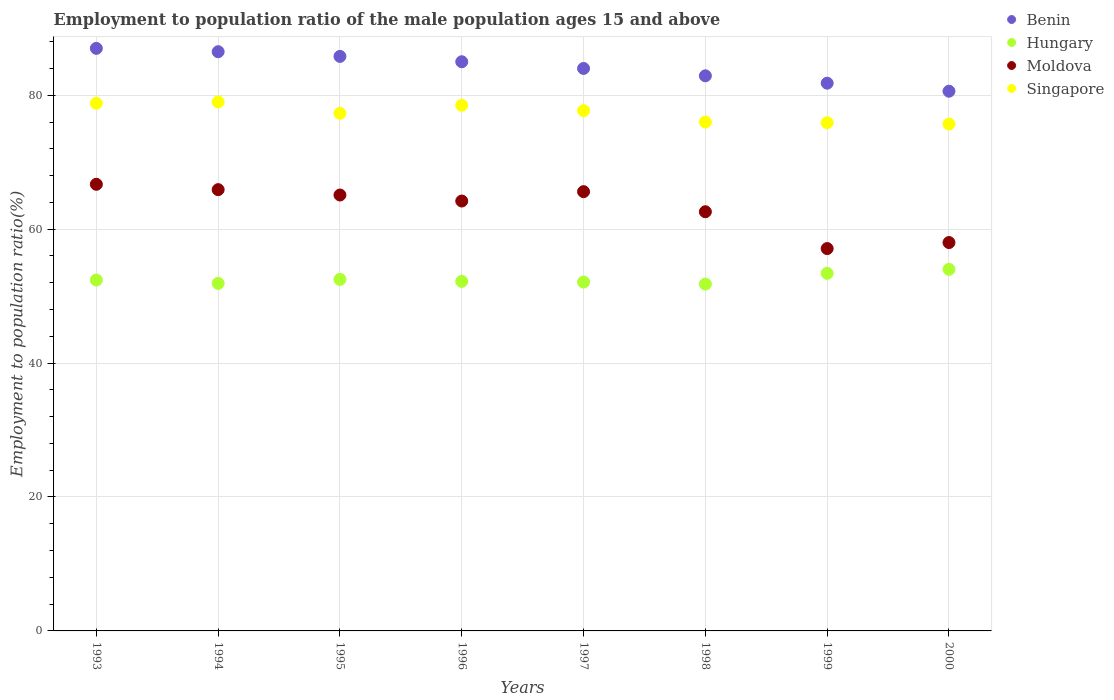How many different coloured dotlines are there?
Give a very brief answer. 4. What is the employment to population ratio in Hungary in 1998?
Your answer should be compact. 51.8. Across all years, what is the maximum employment to population ratio in Singapore?
Ensure brevity in your answer.  79. Across all years, what is the minimum employment to population ratio in Hungary?
Your answer should be compact. 51.8. What is the total employment to population ratio in Hungary in the graph?
Give a very brief answer. 420.3. What is the difference between the employment to population ratio in Moldova in 1997 and that in 1998?
Provide a short and direct response. 3. What is the difference between the employment to population ratio in Singapore in 1994 and the employment to population ratio in Benin in 1995?
Your response must be concise. -6.8. What is the average employment to population ratio in Singapore per year?
Your answer should be compact. 77.36. In the year 1997, what is the difference between the employment to population ratio in Moldova and employment to population ratio in Benin?
Your answer should be compact. -18.4. In how many years, is the employment to population ratio in Singapore greater than 84 %?
Keep it short and to the point. 0. What is the ratio of the employment to population ratio in Hungary in 1997 to that in 1998?
Your answer should be compact. 1.01. What is the difference between the highest and the second highest employment to population ratio in Singapore?
Keep it short and to the point. 0.2. What is the difference between the highest and the lowest employment to population ratio in Singapore?
Offer a very short reply. 3.3. In how many years, is the employment to population ratio in Benin greater than the average employment to population ratio in Benin taken over all years?
Offer a terse response. 4. Is it the case that in every year, the sum of the employment to population ratio in Hungary and employment to population ratio in Benin  is greater than the sum of employment to population ratio in Singapore and employment to population ratio in Moldova?
Provide a short and direct response. No. Is the employment to population ratio in Hungary strictly less than the employment to population ratio in Benin over the years?
Give a very brief answer. Yes. Are the values on the major ticks of Y-axis written in scientific E-notation?
Your answer should be very brief. No. Where does the legend appear in the graph?
Your answer should be very brief. Top right. How many legend labels are there?
Keep it short and to the point. 4. How are the legend labels stacked?
Give a very brief answer. Vertical. What is the title of the graph?
Offer a terse response. Employment to population ratio of the male population ages 15 and above. What is the label or title of the X-axis?
Keep it short and to the point. Years. What is the label or title of the Y-axis?
Offer a terse response. Employment to population ratio(%). What is the Employment to population ratio(%) of Hungary in 1993?
Your answer should be compact. 52.4. What is the Employment to population ratio(%) of Moldova in 1993?
Your answer should be very brief. 66.7. What is the Employment to population ratio(%) of Singapore in 1993?
Offer a terse response. 78.8. What is the Employment to population ratio(%) in Benin in 1994?
Your answer should be very brief. 86.5. What is the Employment to population ratio(%) of Hungary in 1994?
Your answer should be compact. 51.9. What is the Employment to population ratio(%) in Moldova in 1994?
Your answer should be compact. 65.9. What is the Employment to population ratio(%) of Singapore in 1994?
Keep it short and to the point. 79. What is the Employment to population ratio(%) in Benin in 1995?
Your answer should be very brief. 85.8. What is the Employment to population ratio(%) of Hungary in 1995?
Your response must be concise. 52.5. What is the Employment to population ratio(%) in Moldova in 1995?
Make the answer very short. 65.1. What is the Employment to population ratio(%) in Singapore in 1995?
Your answer should be very brief. 77.3. What is the Employment to population ratio(%) in Hungary in 1996?
Give a very brief answer. 52.2. What is the Employment to population ratio(%) in Moldova in 1996?
Offer a terse response. 64.2. What is the Employment to population ratio(%) in Singapore in 1996?
Offer a very short reply. 78.5. What is the Employment to population ratio(%) of Hungary in 1997?
Give a very brief answer. 52.1. What is the Employment to population ratio(%) of Moldova in 1997?
Your answer should be very brief. 65.6. What is the Employment to population ratio(%) in Singapore in 1997?
Your answer should be very brief. 77.7. What is the Employment to population ratio(%) in Benin in 1998?
Provide a succinct answer. 82.9. What is the Employment to population ratio(%) of Hungary in 1998?
Keep it short and to the point. 51.8. What is the Employment to population ratio(%) in Moldova in 1998?
Offer a very short reply. 62.6. What is the Employment to population ratio(%) in Singapore in 1998?
Keep it short and to the point. 76. What is the Employment to population ratio(%) of Benin in 1999?
Provide a succinct answer. 81.8. What is the Employment to population ratio(%) in Hungary in 1999?
Give a very brief answer. 53.4. What is the Employment to population ratio(%) of Moldova in 1999?
Your answer should be compact. 57.1. What is the Employment to population ratio(%) in Singapore in 1999?
Make the answer very short. 75.9. What is the Employment to population ratio(%) in Benin in 2000?
Provide a succinct answer. 80.6. What is the Employment to population ratio(%) of Moldova in 2000?
Keep it short and to the point. 58. What is the Employment to population ratio(%) in Singapore in 2000?
Offer a terse response. 75.7. Across all years, what is the maximum Employment to population ratio(%) in Hungary?
Offer a very short reply. 54. Across all years, what is the maximum Employment to population ratio(%) of Moldova?
Ensure brevity in your answer.  66.7. Across all years, what is the maximum Employment to population ratio(%) of Singapore?
Provide a succinct answer. 79. Across all years, what is the minimum Employment to population ratio(%) in Benin?
Give a very brief answer. 80.6. Across all years, what is the minimum Employment to population ratio(%) of Hungary?
Provide a succinct answer. 51.8. Across all years, what is the minimum Employment to population ratio(%) of Moldova?
Offer a very short reply. 57.1. Across all years, what is the minimum Employment to population ratio(%) of Singapore?
Keep it short and to the point. 75.7. What is the total Employment to population ratio(%) of Benin in the graph?
Your response must be concise. 673.6. What is the total Employment to population ratio(%) of Hungary in the graph?
Your answer should be compact. 420.3. What is the total Employment to population ratio(%) of Moldova in the graph?
Keep it short and to the point. 505.2. What is the total Employment to population ratio(%) of Singapore in the graph?
Your answer should be very brief. 618.9. What is the difference between the Employment to population ratio(%) of Benin in 1993 and that in 1994?
Ensure brevity in your answer.  0.5. What is the difference between the Employment to population ratio(%) of Hungary in 1993 and that in 1994?
Offer a very short reply. 0.5. What is the difference between the Employment to population ratio(%) of Benin in 1993 and that in 1995?
Your answer should be very brief. 1.2. What is the difference between the Employment to population ratio(%) of Benin in 1993 and that in 1996?
Provide a succinct answer. 2. What is the difference between the Employment to population ratio(%) in Hungary in 1993 and that in 1996?
Your response must be concise. 0.2. What is the difference between the Employment to population ratio(%) of Moldova in 1993 and that in 1996?
Make the answer very short. 2.5. What is the difference between the Employment to population ratio(%) of Hungary in 1993 and that in 1997?
Your answer should be compact. 0.3. What is the difference between the Employment to population ratio(%) in Moldova in 1993 and that in 1997?
Your response must be concise. 1.1. What is the difference between the Employment to population ratio(%) in Singapore in 1993 and that in 1997?
Make the answer very short. 1.1. What is the difference between the Employment to population ratio(%) of Benin in 1993 and that in 1999?
Provide a succinct answer. 5.2. What is the difference between the Employment to population ratio(%) in Hungary in 1993 and that in 1999?
Your answer should be compact. -1. What is the difference between the Employment to population ratio(%) of Benin in 1993 and that in 2000?
Offer a very short reply. 6.4. What is the difference between the Employment to population ratio(%) in Hungary in 1993 and that in 2000?
Offer a terse response. -1.6. What is the difference between the Employment to population ratio(%) of Singapore in 1993 and that in 2000?
Provide a short and direct response. 3.1. What is the difference between the Employment to population ratio(%) of Benin in 1994 and that in 1995?
Give a very brief answer. 0.7. What is the difference between the Employment to population ratio(%) in Moldova in 1994 and that in 1995?
Your response must be concise. 0.8. What is the difference between the Employment to population ratio(%) of Benin in 1994 and that in 1996?
Keep it short and to the point. 1.5. What is the difference between the Employment to population ratio(%) in Hungary in 1994 and that in 1996?
Keep it short and to the point. -0.3. What is the difference between the Employment to population ratio(%) in Moldova in 1994 and that in 1996?
Offer a very short reply. 1.7. What is the difference between the Employment to population ratio(%) in Benin in 1994 and that in 1997?
Give a very brief answer. 2.5. What is the difference between the Employment to population ratio(%) in Moldova in 1994 and that in 1997?
Provide a short and direct response. 0.3. What is the difference between the Employment to population ratio(%) of Singapore in 1994 and that in 1997?
Offer a terse response. 1.3. What is the difference between the Employment to population ratio(%) in Hungary in 1994 and that in 1998?
Provide a succinct answer. 0.1. What is the difference between the Employment to population ratio(%) of Moldova in 1994 and that in 1998?
Your answer should be very brief. 3.3. What is the difference between the Employment to population ratio(%) of Singapore in 1994 and that in 1998?
Make the answer very short. 3. What is the difference between the Employment to population ratio(%) in Benin in 1994 and that in 1999?
Your answer should be compact. 4.7. What is the difference between the Employment to population ratio(%) of Singapore in 1994 and that in 1999?
Your answer should be very brief. 3.1. What is the difference between the Employment to population ratio(%) in Hungary in 1994 and that in 2000?
Your answer should be very brief. -2.1. What is the difference between the Employment to population ratio(%) in Benin in 1995 and that in 1996?
Ensure brevity in your answer.  0.8. What is the difference between the Employment to population ratio(%) in Benin in 1995 and that in 1997?
Provide a succinct answer. 1.8. What is the difference between the Employment to population ratio(%) in Singapore in 1995 and that in 1997?
Give a very brief answer. -0.4. What is the difference between the Employment to population ratio(%) in Benin in 1995 and that in 1998?
Offer a terse response. 2.9. What is the difference between the Employment to population ratio(%) of Moldova in 1995 and that in 1998?
Offer a very short reply. 2.5. What is the difference between the Employment to population ratio(%) of Hungary in 1995 and that in 1999?
Ensure brevity in your answer.  -0.9. What is the difference between the Employment to population ratio(%) of Singapore in 1995 and that in 1999?
Your answer should be very brief. 1.4. What is the difference between the Employment to population ratio(%) in Hungary in 1995 and that in 2000?
Provide a succinct answer. -1.5. What is the difference between the Employment to population ratio(%) of Moldova in 1995 and that in 2000?
Give a very brief answer. 7.1. What is the difference between the Employment to population ratio(%) in Benin in 1996 and that in 1997?
Your answer should be very brief. 1. What is the difference between the Employment to population ratio(%) in Hungary in 1996 and that in 1997?
Ensure brevity in your answer.  0.1. What is the difference between the Employment to population ratio(%) of Singapore in 1996 and that in 1998?
Provide a short and direct response. 2.5. What is the difference between the Employment to population ratio(%) of Hungary in 1996 and that in 1999?
Make the answer very short. -1.2. What is the difference between the Employment to population ratio(%) in Benin in 1996 and that in 2000?
Offer a terse response. 4.4. What is the difference between the Employment to population ratio(%) of Moldova in 1996 and that in 2000?
Your response must be concise. 6.2. What is the difference between the Employment to population ratio(%) of Singapore in 1996 and that in 2000?
Offer a terse response. 2.8. What is the difference between the Employment to population ratio(%) of Moldova in 1997 and that in 2000?
Ensure brevity in your answer.  7.6. What is the difference between the Employment to population ratio(%) in Singapore in 1997 and that in 2000?
Your answer should be very brief. 2. What is the difference between the Employment to population ratio(%) in Hungary in 1998 and that in 1999?
Your answer should be very brief. -1.6. What is the difference between the Employment to population ratio(%) of Moldova in 1998 and that in 1999?
Offer a terse response. 5.5. What is the difference between the Employment to population ratio(%) of Singapore in 1998 and that in 1999?
Your answer should be very brief. 0.1. What is the difference between the Employment to population ratio(%) of Hungary in 1998 and that in 2000?
Keep it short and to the point. -2.2. What is the difference between the Employment to population ratio(%) in Benin in 1999 and that in 2000?
Your response must be concise. 1.2. What is the difference between the Employment to population ratio(%) of Singapore in 1999 and that in 2000?
Your response must be concise. 0.2. What is the difference between the Employment to population ratio(%) of Benin in 1993 and the Employment to population ratio(%) of Hungary in 1994?
Provide a succinct answer. 35.1. What is the difference between the Employment to population ratio(%) of Benin in 1993 and the Employment to population ratio(%) of Moldova in 1994?
Offer a terse response. 21.1. What is the difference between the Employment to population ratio(%) of Benin in 1993 and the Employment to population ratio(%) of Singapore in 1994?
Offer a very short reply. 8. What is the difference between the Employment to population ratio(%) of Hungary in 1993 and the Employment to population ratio(%) of Singapore in 1994?
Your answer should be compact. -26.6. What is the difference between the Employment to population ratio(%) in Moldova in 1993 and the Employment to population ratio(%) in Singapore in 1994?
Keep it short and to the point. -12.3. What is the difference between the Employment to population ratio(%) in Benin in 1993 and the Employment to population ratio(%) in Hungary in 1995?
Provide a short and direct response. 34.5. What is the difference between the Employment to population ratio(%) of Benin in 1993 and the Employment to population ratio(%) of Moldova in 1995?
Ensure brevity in your answer.  21.9. What is the difference between the Employment to population ratio(%) of Hungary in 1993 and the Employment to population ratio(%) of Singapore in 1995?
Your answer should be compact. -24.9. What is the difference between the Employment to population ratio(%) of Benin in 1993 and the Employment to population ratio(%) of Hungary in 1996?
Your answer should be compact. 34.8. What is the difference between the Employment to population ratio(%) of Benin in 1993 and the Employment to population ratio(%) of Moldova in 1996?
Give a very brief answer. 22.8. What is the difference between the Employment to population ratio(%) in Benin in 1993 and the Employment to population ratio(%) in Singapore in 1996?
Keep it short and to the point. 8.5. What is the difference between the Employment to population ratio(%) of Hungary in 1993 and the Employment to population ratio(%) of Moldova in 1996?
Offer a very short reply. -11.8. What is the difference between the Employment to population ratio(%) of Hungary in 1993 and the Employment to population ratio(%) of Singapore in 1996?
Your answer should be very brief. -26.1. What is the difference between the Employment to population ratio(%) in Moldova in 1993 and the Employment to population ratio(%) in Singapore in 1996?
Your answer should be compact. -11.8. What is the difference between the Employment to population ratio(%) in Benin in 1993 and the Employment to population ratio(%) in Hungary in 1997?
Make the answer very short. 34.9. What is the difference between the Employment to population ratio(%) in Benin in 1993 and the Employment to population ratio(%) in Moldova in 1997?
Give a very brief answer. 21.4. What is the difference between the Employment to population ratio(%) of Benin in 1993 and the Employment to population ratio(%) of Singapore in 1997?
Keep it short and to the point. 9.3. What is the difference between the Employment to population ratio(%) of Hungary in 1993 and the Employment to population ratio(%) of Moldova in 1997?
Keep it short and to the point. -13.2. What is the difference between the Employment to population ratio(%) of Hungary in 1993 and the Employment to population ratio(%) of Singapore in 1997?
Keep it short and to the point. -25.3. What is the difference between the Employment to population ratio(%) in Benin in 1993 and the Employment to population ratio(%) in Hungary in 1998?
Your response must be concise. 35.2. What is the difference between the Employment to population ratio(%) of Benin in 1993 and the Employment to population ratio(%) of Moldova in 1998?
Ensure brevity in your answer.  24.4. What is the difference between the Employment to population ratio(%) in Benin in 1993 and the Employment to population ratio(%) in Singapore in 1998?
Provide a short and direct response. 11. What is the difference between the Employment to population ratio(%) in Hungary in 1993 and the Employment to population ratio(%) in Moldova in 1998?
Provide a short and direct response. -10.2. What is the difference between the Employment to population ratio(%) of Hungary in 1993 and the Employment to population ratio(%) of Singapore in 1998?
Offer a terse response. -23.6. What is the difference between the Employment to population ratio(%) in Moldova in 1993 and the Employment to population ratio(%) in Singapore in 1998?
Provide a succinct answer. -9.3. What is the difference between the Employment to population ratio(%) in Benin in 1993 and the Employment to population ratio(%) in Hungary in 1999?
Keep it short and to the point. 33.6. What is the difference between the Employment to population ratio(%) in Benin in 1993 and the Employment to population ratio(%) in Moldova in 1999?
Your response must be concise. 29.9. What is the difference between the Employment to population ratio(%) of Hungary in 1993 and the Employment to population ratio(%) of Moldova in 1999?
Provide a succinct answer. -4.7. What is the difference between the Employment to population ratio(%) in Hungary in 1993 and the Employment to population ratio(%) in Singapore in 1999?
Your answer should be compact. -23.5. What is the difference between the Employment to population ratio(%) in Benin in 1993 and the Employment to population ratio(%) in Hungary in 2000?
Keep it short and to the point. 33. What is the difference between the Employment to population ratio(%) of Hungary in 1993 and the Employment to population ratio(%) of Singapore in 2000?
Your response must be concise. -23.3. What is the difference between the Employment to population ratio(%) in Moldova in 1993 and the Employment to population ratio(%) in Singapore in 2000?
Provide a succinct answer. -9. What is the difference between the Employment to population ratio(%) of Benin in 1994 and the Employment to population ratio(%) of Moldova in 1995?
Ensure brevity in your answer.  21.4. What is the difference between the Employment to population ratio(%) in Benin in 1994 and the Employment to population ratio(%) in Singapore in 1995?
Ensure brevity in your answer.  9.2. What is the difference between the Employment to population ratio(%) in Hungary in 1994 and the Employment to population ratio(%) in Singapore in 1995?
Keep it short and to the point. -25.4. What is the difference between the Employment to population ratio(%) of Benin in 1994 and the Employment to population ratio(%) of Hungary in 1996?
Make the answer very short. 34.3. What is the difference between the Employment to population ratio(%) in Benin in 1994 and the Employment to population ratio(%) in Moldova in 1996?
Provide a succinct answer. 22.3. What is the difference between the Employment to population ratio(%) in Benin in 1994 and the Employment to population ratio(%) in Singapore in 1996?
Offer a very short reply. 8. What is the difference between the Employment to population ratio(%) in Hungary in 1994 and the Employment to population ratio(%) in Singapore in 1996?
Make the answer very short. -26.6. What is the difference between the Employment to population ratio(%) in Moldova in 1994 and the Employment to population ratio(%) in Singapore in 1996?
Offer a very short reply. -12.6. What is the difference between the Employment to population ratio(%) of Benin in 1994 and the Employment to population ratio(%) of Hungary in 1997?
Provide a succinct answer. 34.4. What is the difference between the Employment to population ratio(%) of Benin in 1994 and the Employment to population ratio(%) of Moldova in 1997?
Your answer should be very brief. 20.9. What is the difference between the Employment to population ratio(%) in Hungary in 1994 and the Employment to population ratio(%) in Moldova in 1997?
Offer a terse response. -13.7. What is the difference between the Employment to population ratio(%) of Hungary in 1994 and the Employment to population ratio(%) of Singapore in 1997?
Your answer should be very brief. -25.8. What is the difference between the Employment to population ratio(%) in Moldova in 1994 and the Employment to population ratio(%) in Singapore in 1997?
Provide a short and direct response. -11.8. What is the difference between the Employment to population ratio(%) in Benin in 1994 and the Employment to population ratio(%) in Hungary in 1998?
Make the answer very short. 34.7. What is the difference between the Employment to population ratio(%) in Benin in 1994 and the Employment to population ratio(%) in Moldova in 1998?
Your response must be concise. 23.9. What is the difference between the Employment to population ratio(%) in Benin in 1994 and the Employment to population ratio(%) in Singapore in 1998?
Your answer should be very brief. 10.5. What is the difference between the Employment to population ratio(%) of Hungary in 1994 and the Employment to population ratio(%) of Singapore in 1998?
Offer a terse response. -24.1. What is the difference between the Employment to population ratio(%) of Moldova in 1994 and the Employment to population ratio(%) of Singapore in 1998?
Keep it short and to the point. -10.1. What is the difference between the Employment to population ratio(%) in Benin in 1994 and the Employment to population ratio(%) in Hungary in 1999?
Your answer should be very brief. 33.1. What is the difference between the Employment to population ratio(%) of Benin in 1994 and the Employment to population ratio(%) of Moldova in 1999?
Make the answer very short. 29.4. What is the difference between the Employment to population ratio(%) in Benin in 1994 and the Employment to population ratio(%) in Singapore in 1999?
Your response must be concise. 10.6. What is the difference between the Employment to population ratio(%) in Hungary in 1994 and the Employment to population ratio(%) in Moldova in 1999?
Make the answer very short. -5.2. What is the difference between the Employment to population ratio(%) in Moldova in 1994 and the Employment to population ratio(%) in Singapore in 1999?
Your response must be concise. -10. What is the difference between the Employment to population ratio(%) in Benin in 1994 and the Employment to population ratio(%) in Hungary in 2000?
Offer a terse response. 32.5. What is the difference between the Employment to population ratio(%) of Benin in 1994 and the Employment to population ratio(%) of Moldova in 2000?
Offer a terse response. 28.5. What is the difference between the Employment to population ratio(%) of Hungary in 1994 and the Employment to population ratio(%) of Moldova in 2000?
Offer a terse response. -6.1. What is the difference between the Employment to population ratio(%) in Hungary in 1994 and the Employment to population ratio(%) in Singapore in 2000?
Your response must be concise. -23.8. What is the difference between the Employment to population ratio(%) in Moldova in 1994 and the Employment to population ratio(%) in Singapore in 2000?
Your answer should be very brief. -9.8. What is the difference between the Employment to population ratio(%) of Benin in 1995 and the Employment to population ratio(%) of Hungary in 1996?
Your response must be concise. 33.6. What is the difference between the Employment to population ratio(%) in Benin in 1995 and the Employment to population ratio(%) in Moldova in 1996?
Your answer should be very brief. 21.6. What is the difference between the Employment to population ratio(%) of Moldova in 1995 and the Employment to population ratio(%) of Singapore in 1996?
Offer a very short reply. -13.4. What is the difference between the Employment to population ratio(%) in Benin in 1995 and the Employment to population ratio(%) in Hungary in 1997?
Provide a succinct answer. 33.7. What is the difference between the Employment to population ratio(%) of Benin in 1995 and the Employment to population ratio(%) of Moldova in 1997?
Make the answer very short. 20.2. What is the difference between the Employment to population ratio(%) of Benin in 1995 and the Employment to population ratio(%) of Singapore in 1997?
Give a very brief answer. 8.1. What is the difference between the Employment to population ratio(%) of Hungary in 1995 and the Employment to population ratio(%) of Singapore in 1997?
Your response must be concise. -25.2. What is the difference between the Employment to population ratio(%) in Moldova in 1995 and the Employment to population ratio(%) in Singapore in 1997?
Ensure brevity in your answer.  -12.6. What is the difference between the Employment to population ratio(%) in Benin in 1995 and the Employment to population ratio(%) in Hungary in 1998?
Make the answer very short. 34. What is the difference between the Employment to population ratio(%) of Benin in 1995 and the Employment to population ratio(%) of Moldova in 1998?
Offer a very short reply. 23.2. What is the difference between the Employment to population ratio(%) of Hungary in 1995 and the Employment to population ratio(%) of Moldova in 1998?
Ensure brevity in your answer.  -10.1. What is the difference between the Employment to population ratio(%) of Hungary in 1995 and the Employment to population ratio(%) of Singapore in 1998?
Your answer should be very brief. -23.5. What is the difference between the Employment to population ratio(%) of Moldova in 1995 and the Employment to population ratio(%) of Singapore in 1998?
Your response must be concise. -10.9. What is the difference between the Employment to population ratio(%) in Benin in 1995 and the Employment to population ratio(%) in Hungary in 1999?
Offer a terse response. 32.4. What is the difference between the Employment to population ratio(%) of Benin in 1995 and the Employment to population ratio(%) of Moldova in 1999?
Give a very brief answer. 28.7. What is the difference between the Employment to population ratio(%) of Benin in 1995 and the Employment to population ratio(%) of Singapore in 1999?
Provide a short and direct response. 9.9. What is the difference between the Employment to population ratio(%) of Hungary in 1995 and the Employment to population ratio(%) of Moldova in 1999?
Provide a succinct answer. -4.6. What is the difference between the Employment to population ratio(%) in Hungary in 1995 and the Employment to population ratio(%) in Singapore in 1999?
Provide a succinct answer. -23.4. What is the difference between the Employment to population ratio(%) in Benin in 1995 and the Employment to population ratio(%) in Hungary in 2000?
Your answer should be compact. 31.8. What is the difference between the Employment to population ratio(%) in Benin in 1995 and the Employment to population ratio(%) in Moldova in 2000?
Provide a succinct answer. 27.8. What is the difference between the Employment to population ratio(%) in Hungary in 1995 and the Employment to population ratio(%) in Singapore in 2000?
Give a very brief answer. -23.2. What is the difference between the Employment to population ratio(%) of Benin in 1996 and the Employment to population ratio(%) of Hungary in 1997?
Offer a very short reply. 32.9. What is the difference between the Employment to population ratio(%) of Hungary in 1996 and the Employment to population ratio(%) of Singapore in 1997?
Provide a short and direct response. -25.5. What is the difference between the Employment to population ratio(%) in Moldova in 1996 and the Employment to population ratio(%) in Singapore in 1997?
Your answer should be very brief. -13.5. What is the difference between the Employment to population ratio(%) in Benin in 1996 and the Employment to population ratio(%) in Hungary in 1998?
Your answer should be very brief. 33.2. What is the difference between the Employment to population ratio(%) in Benin in 1996 and the Employment to population ratio(%) in Moldova in 1998?
Your response must be concise. 22.4. What is the difference between the Employment to population ratio(%) of Hungary in 1996 and the Employment to population ratio(%) of Moldova in 1998?
Give a very brief answer. -10.4. What is the difference between the Employment to population ratio(%) of Hungary in 1996 and the Employment to population ratio(%) of Singapore in 1998?
Provide a short and direct response. -23.8. What is the difference between the Employment to population ratio(%) in Benin in 1996 and the Employment to population ratio(%) in Hungary in 1999?
Offer a very short reply. 31.6. What is the difference between the Employment to population ratio(%) in Benin in 1996 and the Employment to population ratio(%) in Moldova in 1999?
Give a very brief answer. 27.9. What is the difference between the Employment to population ratio(%) in Benin in 1996 and the Employment to population ratio(%) in Singapore in 1999?
Offer a terse response. 9.1. What is the difference between the Employment to population ratio(%) in Hungary in 1996 and the Employment to population ratio(%) in Moldova in 1999?
Your answer should be very brief. -4.9. What is the difference between the Employment to population ratio(%) of Hungary in 1996 and the Employment to population ratio(%) of Singapore in 1999?
Give a very brief answer. -23.7. What is the difference between the Employment to population ratio(%) in Benin in 1996 and the Employment to population ratio(%) in Hungary in 2000?
Make the answer very short. 31. What is the difference between the Employment to population ratio(%) in Benin in 1996 and the Employment to population ratio(%) in Moldova in 2000?
Offer a terse response. 27. What is the difference between the Employment to population ratio(%) of Benin in 1996 and the Employment to population ratio(%) of Singapore in 2000?
Give a very brief answer. 9.3. What is the difference between the Employment to population ratio(%) of Hungary in 1996 and the Employment to population ratio(%) of Moldova in 2000?
Provide a short and direct response. -5.8. What is the difference between the Employment to population ratio(%) of Hungary in 1996 and the Employment to population ratio(%) of Singapore in 2000?
Your response must be concise. -23.5. What is the difference between the Employment to population ratio(%) of Benin in 1997 and the Employment to population ratio(%) of Hungary in 1998?
Offer a terse response. 32.2. What is the difference between the Employment to population ratio(%) in Benin in 1997 and the Employment to population ratio(%) in Moldova in 1998?
Make the answer very short. 21.4. What is the difference between the Employment to population ratio(%) in Benin in 1997 and the Employment to population ratio(%) in Singapore in 1998?
Your answer should be very brief. 8. What is the difference between the Employment to population ratio(%) in Hungary in 1997 and the Employment to population ratio(%) in Singapore in 1998?
Give a very brief answer. -23.9. What is the difference between the Employment to population ratio(%) in Moldova in 1997 and the Employment to population ratio(%) in Singapore in 1998?
Offer a very short reply. -10.4. What is the difference between the Employment to population ratio(%) of Benin in 1997 and the Employment to population ratio(%) of Hungary in 1999?
Ensure brevity in your answer.  30.6. What is the difference between the Employment to population ratio(%) of Benin in 1997 and the Employment to population ratio(%) of Moldova in 1999?
Your answer should be compact. 26.9. What is the difference between the Employment to population ratio(%) in Benin in 1997 and the Employment to population ratio(%) in Singapore in 1999?
Ensure brevity in your answer.  8.1. What is the difference between the Employment to population ratio(%) of Hungary in 1997 and the Employment to population ratio(%) of Moldova in 1999?
Your answer should be compact. -5. What is the difference between the Employment to population ratio(%) of Hungary in 1997 and the Employment to population ratio(%) of Singapore in 1999?
Your answer should be very brief. -23.8. What is the difference between the Employment to population ratio(%) in Moldova in 1997 and the Employment to population ratio(%) in Singapore in 1999?
Your answer should be compact. -10.3. What is the difference between the Employment to population ratio(%) in Benin in 1997 and the Employment to population ratio(%) in Hungary in 2000?
Give a very brief answer. 30. What is the difference between the Employment to population ratio(%) in Benin in 1997 and the Employment to population ratio(%) in Moldova in 2000?
Give a very brief answer. 26. What is the difference between the Employment to population ratio(%) in Hungary in 1997 and the Employment to population ratio(%) in Singapore in 2000?
Provide a short and direct response. -23.6. What is the difference between the Employment to population ratio(%) of Moldova in 1997 and the Employment to population ratio(%) of Singapore in 2000?
Your answer should be very brief. -10.1. What is the difference between the Employment to population ratio(%) of Benin in 1998 and the Employment to population ratio(%) of Hungary in 1999?
Provide a succinct answer. 29.5. What is the difference between the Employment to population ratio(%) of Benin in 1998 and the Employment to population ratio(%) of Moldova in 1999?
Give a very brief answer. 25.8. What is the difference between the Employment to population ratio(%) of Benin in 1998 and the Employment to population ratio(%) of Singapore in 1999?
Provide a short and direct response. 7. What is the difference between the Employment to population ratio(%) of Hungary in 1998 and the Employment to population ratio(%) of Singapore in 1999?
Give a very brief answer. -24.1. What is the difference between the Employment to population ratio(%) of Moldova in 1998 and the Employment to population ratio(%) of Singapore in 1999?
Offer a terse response. -13.3. What is the difference between the Employment to population ratio(%) in Benin in 1998 and the Employment to population ratio(%) in Hungary in 2000?
Provide a short and direct response. 28.9. What is the difference between the Employment to population ratio(%) in Benin in 1998 and the Employment to population ratio(%) in Moldova in 2000?
Your answer should be very brief. 24.9. What is the difference between the Employment to population ratio(%) in Benin in 1998 and the Employment to population ratio(%) in Singapore in 2000?
Keep it short and to the point. 7.2. What is the difference between the Employment to population ratio(%) of Hungary in 1998 and the Employment to population ratio(%) of Moldova in 2000?
Make the answer very short. -6.2. What is the difference between the Employment to population ratio(%) of Hungary in 1998 and the Employment to population ratio(%) of Singapore in 2000?
Your answer should be compact. -23.9. What is the difference between the Employment to population ratio(%) of Moldova in 1998 and the Employment to population ratio(%) of Singapore in 2000?
Give a very brief answer. -13.1. What is the difference between the Employment to population ratio(%) of Benin in 1999 and the Employment to population ratio(%) of Hungary in 2000?
Provide a short and direct response. 27.8. What is the difference between the Employment to population ratio(%) in Benin in 1999 and the Employment to population ratio(%) in Moldova in 2000?
Offer a terse response. 23.8. What is the difference between the Employment to population ratio(%) of Benin in 1999 and the Employment to population ratio(%) of Singapore in 2000?
Your answer should be very brief. 6.1. What is the difference between the Employment to population ratio(%) in Hungary in 1999 and the Employment to population ratio(%) in Singapore in 2000?
Provide a short and direct response. -22.3. What is the difference between the Employment to population ratio(%) of Moldova in 1999 and the Employment to population ratio(%) of Singapore in 2000?
Offer a very short reply. -18.6. What is the average Employment to population ratio(%) in Benin per year?
Provide a succinct answer. 84.2. What is the average Employment to population ratio(%) of Hungary per year?
Keep it short and to the point. 52.54. What is the average Employment to population ratio(%) in Moldova per year?
Give a very brief answer. 63.15. What is the average Employment to population ratio(%) in Singapore per year?
Provide a succinct answer. 77.36. In the year 1993, what is the difference between the Employment to population ratio(%) in Benin and Employment to population ratio(%) in Hungary?
Give a very brief answer. 34.6. In the year 1993, what is the difference between the Employment to population ratio(%) of Benin and Employment to population ratio(%) of Moldova?
Ensure brevity in your answer.  20.3. In the year 1993, what is the difference between the Employment to population ratio(%) in Hungary and Employment to population ratio(%) in Moldova?
Ensure brevity in your answer.  -14.3. In the year 1993, what is the difference between the Employment to population ratio(%) in Hungary and Employment to population ratio(%) in Singapore?
Provide a succinct answer. -26.4. In the year 1993, what is the difference between the Employment to population ratio(%) of Moldova and Employment to population ratio(%) of Singapore?
Make the answer very short. -12.1. In the year 1994, what is the difference between the Employment to population ratio(%) in Benin and Employment to population ratio(%) in Hungary?
Your response must be concise. 34.6. In the year 1994, what is the difference between the Employment to population ratio(%) in Benin and Employment to population ratio(%) in Moldova?
Give a very brief answer. 20.6. In the year 1994, what is the difference between the Employment to population ratio(%) in Hungary and Employment to population ratio(%) in Singapore?
Give a very brief answer. -27.1. In the year 1994, what is the difference between the Employment to population ratio(%) of Moldova and Employment to population ratio(%) of Singapore?
Your answer should be very brief. -13.1. In the year 1995, what is the difference between the Employment to population ratio(%) in Benin and Employment to population ratio(%) in Hungary?
Offer a terse response. 33.3. In the year 1995, what is the difference between the Employment to population ratio(%) in Benin and Employment to population ratio(%) in Moldova?
Your answer should be compact. 20.7. In the year 1995, what is the difference between the Employment to population ratio(%) of Benin and Employment to population ratio(%) of Singapore?
Your answer should be compact. 8.5. In the year 1995, what is the difference between the Employment to population ratio(%) in Hungary and Employment to population ratio(%) in Singapore?
Your response must be concise. -24.8. In the year 1995, what is the difference between the Employment to population ratio(%) of Moldova and Employment to population ratio(%) of Singapore?
Your answer should be very brief. -12.2. In the year 1996, what is the difference between the Employment to population ratio(%) of Benin and Employment to population ratio(%) of Hungary?
Your response must be concise. 32.8. In the year 1996, what is the difference between the Employment to population ratio(%) of Benin and Employment to population ratio(%) of Moldova?
Offer a terse response. 20.8. In the year 1996, what is the difference between the Employment to population ratio(%) in Hungary and Employment to population ratio(%) in Singapore?
Provide a succinct answer. -26.3. In the year 1996, what is the difference between the Employment to population ratio(%) of Moldova and Employment to population ratio(%) of Singapore?
Keep it short and to the point. -14.3. In the year 1997, what is the difference between the Employment to population ratio(%) of Benin and Employment to population ratio(%) of Hungary?
Your answer should be very brief. 31.9. In the year 1997, what is the difference between the Employment to population ratio(%) of Benin and Employment to population ratio(%) of Singapore?
Keep it short and to the point. 6.3. In the year 1997, what is the difference between the Employment to population ratio(%) of Hungary and Employment to population ratio(%) of Singapore?
Ensure brevity in your answer.  -25.6. In the year 1997, what is the difference between the Employment to population ratio(%) of Moldova and Employment to population ratio(%) of Singapore?
Ensure brevity in your answer.  -12.1. In the year 1998, what is the difference between the Employment to population ratio(%) in Benin and Employment to population ratio(%) in Hungary?
Your answer should be compact. 31.1. In the year 1998, what is the difference between the Employment to population ratio(%) of Benin and Employment to population ratio(%) of Moldova?
Your answer should be compact. 20.3. In the year 1998, what is the difference between the Employment to population ratio(%) of Benin and Employment to population ratio(%) of Singapore?
Your response must be concise. 6.9. In the year 1998, what is the difference between the Employment to population ratio(%) in Hungary and Employment to population ratio(%) in Singapore?
Your answer should be very brief. -24.2. In the year 1998, what is the difference between the Employment to population ratio(%) in Moldova and Employment to population ratio(%) in Singapore?
Your answer should be compact. -13.4. In the year 1999, what is the difference between the Employment to population ratio(%) of Benin and Employment to population ratio(%) of Hungary?
Offer a terse response. 28.4. In the year 1999, what is the difference between the Employment to population ratio(%) in Benin and Employment to population ratio(%) in Moldova?
Make the answer very short. 24.7. In the year 1999, what is the difference between the Employment to population ratio(%) of Hungary and Employment to population ratio(%) of Moldova?
Provide a short and direct response. -3.7. In the year 1999, what is the difference between the Employment to population ratio(%) of Hungary and Employment to population ratio(%) of Singapore?
Offer a very short reply. -22.5. In the year 1999, what is the difference between the Employment to population ratio(%) of Moldova and Employment to population ratio(%) of Singapore?
Keep it short and to the point. -18.8. In the year 2000, what is the difference between the Employment to population ratio(%) of Benin and Employment to population ratio(%) of Hungary?
Provide a succinct answer. 26.6. In the year 2000, what is the difference between the Employment to population ratio(%) of Benin and Employment to population ratio(%) of Moldova?
Make the answer very short. 22.6. In the year 2000, what is the difference between the Employment to population ratio(%) of Benin and Employment to population ratio(%) of Singapore?
Your answer should be compact. 4.9. In the year 2000, what is the difference between the Employment to population ratio(%) in Hungary and Employment to population ratio(%) in Singapore?
Make the answer very short. -21.7. In the year 2000, what is the difference between the Employment to population ratio(%) in Moldova and Employment to population ratio(%) in Singapore?
Offer a very short reply. -17.7. What is the ratio of the Employment to population ratio(%) of Benin in 1993 to that in 1994?
Offer a terse response. 1.01. What is the ratio of the Employment to population ratio(%) in Hungary in 1993 to that in 1994?
Your response must be concise. 1.01. What is the ratio of the Employment to population ratio(%) in Moldova in 1993 to that in 1994?
Provide a short and direct response. 1.01. What is the ratio of the Employment to population ratio(%) of Singapore in 1993 to that in 1994?
Give a very brief answer. 1. What is the ratio of the Employment to population ratio(%) in Benin in 1993 to that in 1995?
Your answer should be compact. 1.01. What is the ratio of the Employment to population ratio(%) of Moldova in 1993 to that in 1995?
Ensure brevity in your answer.  1.02. What is the ratio of the Employment to population ratio(%) of Singapore in 1993 to that in 1995?
Provide a succinct answer. 1.02. What is the ratio of the Employment to population ratio(%) of Benin in 1993 to that in 1996?
Make the answer very short. 1.02. What is the ratio of the Employment to population ratio(%) in Hungary in 1993 to that in 1996?
Your response must be concise. 1. What is the ratio of the Employment to population ratio(%) in Moldova in 1993 to that in 1996?
Provide a short and direct response. 1.04. What is the ratio of the Employment to population ratio(%) in Singapore in 1993 to that in 1996?
Offer a very short reply. 1. What is the ratio of the Employment to population ratio(%) in Benin in 1993 to that in 1997?
Make the answer very short. 1.04. What is the ratio of the Employment to population ratio(%) in Moldova in 1993 to that in 1997?
Offer a very short reply. 1.02. What is the ratio of the Employment to population ratio(%) in Singapore in 1993 to that in 1997?
Provide a short and direct response. 1.01. What is the ratio of the Employment to population ratio(%) of Benin in 1993 to that in 1998?
Offer a terse response. 1.05. What is the ratio of the Employment to population ratio(%) in Hungary in 1993 to that in 1998?
Your answer should be very brief. 1.01. What is the ratio of the Employment to population ratio(%) in Moldova in 1993 to that in 1998?
Your answer should be compact. 1.07. What is the ratio of the Employment to population ratio(%) of Singapore in 1993 to that in 1998?
Make the answer very short. 1.04. What is the ratio of the Employment to population ratio(%) in Benin in 1993 to that in 1999?
Keep it short and to the point. 1.06. What is the ratio of the Employment to population ratio(%) of Hungary in 1993 to that in 1999?
Your answer should be very brief. 0.98. What is the ratio of the Employment to population ratio(%) in Moldova in 1993 to that in 1999?
Your response must be concise. 1.17. What is the ratio of the Employment to population ratio(%) in Singapore in 1993 to that in 1999?
Give a very brief answer. 1.04. What is the ratio of the Employment to population ratio(%) of Benin in 1993 to that in 2000?
Your response must be concise. 1.08. What is the ratio of the Employment to population ratio(%) of Hungary in 1993 to that in 2000?
Offer a very short reply. 0.97. What is the ratio of the Employment to population ratio(%) of Moldova in 1993 to that in 2000?
Give a very brief answer. 1.15. What is the ratio of the Employment to population ratio(%) in Singapore in 1993 to that in 2000?
Provide a short and direct response. 1.04. What is the ratio of the Employment to population ratio(%) in Benin in 1994 to that in 1995?
Give a very brief answer. 1.01. What is the ratio of the Employment to population ratio(%) of Moldova in 1994 to that in 1995?
Ensure brevity in your answer.  1.01. What is the ratio of the Employment to population ratio(%) in Singapore in 1994 to that in 1995?
Provide a short and direct response. 1.02. What is the ratio of the Employment to population ratio(%) of Benin in 1994 to that in 1996?
Give a very brief answer. 1.02. What is the ratio of the Employment to population ratio(%) of Hungary in 1994 to that in 1996?
Give a very brief answer. 0.99. What is the ratio of the Employment to population ratio(%) of Moldova in 1994 to that in 1996?
Offer a very short reply. 1.03. What is the ratio of the Employment to population ratio(%) in Singapore in 1994 to that in 1996?
Offer a very short reply. 1.01. What is the ratio of the Employment to population ratio(%) of Benin in 1994 to that in 1997?
Provide a succinct answer. 1.03. What is the ratio of the Employment to population ratio(%) in Moldova in 1994 to that in 1997?
Make the answer very short. 1. What is the ratio of the Employment to population ratio(%) of Singapore in 1994 to that in 1997?
Make the answer very short. 1.02. What is the ratio of the Employment to population ratio(%) in Benin in 1994 to that in 1998?
Ensure brevity in your answer.  1.04. What is the ratio of the Employment to population ratio(%) of Hungary in 1994 to that in 1998?
Your answer should be very brief. 1. What is the ratio of the Employment to population ratio(%) of Moldova in 1994 to that in 1998?
Keep it short and to the point. 1.05. What is the ratio of the Employment to population ratio(%) of Singapore in 1994 to that in 1998?
Offer a terse response. 1.04. What is the ratio of the Employment to population ratio(%) of Benin in 1994 to that in 1999?
Provide a succinct answer. 1.06. What is the ratio of the Employment to population ratio(%) of Hungary in 1994 to that in 1999?
Keep it short and to the point. 0.97. What is the ratio of the Employment to population ratio(%) in Moldova in 1994 to that in 1999?
Offer a terse response. 1.15. What is the ratio of the Employment to population ratio(%) of Singapore in 1994 to that in 1999?
Provide a succinct answer. 1.04. What is the ratio of the Employment to population ratio(%) of Benin in 1994 to that in 2000?
Keep it short and to the point. 1.07. What is the ratio of the Employment to population ratio(%) in Hungary in 1994 to that in 2000?
Provide a short and direct response. 0.96. What is the ratio of the Employment to population ratio(%) in Moldova in 1994 to that in 2000?
Offer a terse response. 1.14. What is the ratio of the Employment to population ratio(%) in Singapore in 1994 to that in 2000?
Keep it short and to the point. 1.04. What is the ratio of the Employment to population ratio(%) of Benin in 1995 to that in 1996?
Keep it short and to the point. 1.01. What is the ratio of the Employment to population ratio(%) in Hungary in 1995 to that in 1996?
Provide a succinct answer. 1.01. What is the ratio of the Employment to population ratio(%) of Singapore in 1995 to that in 1996?
Keep it short and to the point. 0.98. What is the ratio of the Employment to population ratio(%) of Benin in 1995 to that in 1997?
Offer a very short reply. 1.02. What is the ratio of the Employment to population ratio(%) in Hungary in 1995 to that in 1997?
Provide a succinct answer. 1.01. What is the ratio of the Employment to population ratio(%) of Singapore in 1995 to that in 1997?
Your answer should be very brief. 0.99. What is the ratio of the Employment to population ratio(%) of Benin in 1995 to that in 1998?
Offer a terse response. 1.03. What is the ratio of the Employment to population ratio(%) in Hungary in 1995 to that in 1998?
Give a very brief answer. 1.01. What is the ratio of the Employment to population ratio(%) in Moldova in 1995 to that in 1998?
Offer a very short reply. 1.04. What is the ratio of the Employment to population ratio(%) in Singapore in 1995 to that in 1998?
Your response must be concise. 1.02. What is the ratio of the Employment to population ratio(%) of Benin in 1995 to that in 1999?
Ensure brevity in your answer.  1.05. What is the ratio of the Employment to population ratio(%) of Hungary in 1995 to that in 1999?
Your answer should be compact. 0.98. What is the ratio of the Employment to population ratio(%) of Moldova in 1995 to that in 1999?
Offer a terse response. 1.14. What is the ratio of the Employment to population ratio(%) in Singapore in 1995 to that in 1999?
Keep it short and to the point. 1.02. What is the ratio of the Employment to population ratio(%) in Benin in 1995 to that in 2000?
Keep it short and to the point. 1.06. What is the ratio of the Employment to population ratio(%) in Hungary in 1995 to that in 2000?
Provide a short and direct response. 0.97. What is the ratio of the Employment to population ratio(%) in Moldova in 1995 to that in 2000?
Your response must be concise. 1.12. What is the ratio of the Employment to population ratio(%) of Singapore in 1995 to that in 2000?
Provide a short and direct response. 1.02. What is the ratio of the Employment to population ratio(%) of Benin in 1996 to that in 1997?
Provide a succinct answer. 1.01. What is the ratio of the Employment to population ratio(%) in Moldova in 1996 to that in 1997?
Your response must be concise. 0.98. What is the ratio of the Employment to population ratio(%) of Singapore in 1996 to that in 1997?
Offer a very short reply. 1.01. What is the ratio of the Employment to population ratio(%) of Benin in 1996 to that in 1998?
Make the answer very short. 1.03. What is the ratio of the Employment to population ratio(%) in Hungary in 1996 to that in 1998?
Your answer should be compact. 1.01. What is the ratio of the Employment to population ratio(%) of Moldova in 1996 to that in 1998?
Your answer should be compact. 1.03. What is the ratio of the Employment to population ratio(%) of Singapore in 1996 to that in 1998?
Offer a very short reply. 1.03. What is the ratio of the Employment to population ratio(%) of Benin in 1996 to that in 1999?
Offer a very short reply. 1.04. What is the ratio of the Employment to population ratio(%) of Hungary in 1996 to that in 1999?
Ensure brevity in your answer.  0.98. What is the ratio of the Employment to population ratio(%) in Moldova in 1996 to that in 1999?
Your answer should be very brief. 1.12. What is the ratio of the Employment to population ratio(%) in Singapore in 1996 to that in 1999?
Ensure brevity in your answer.  1.03. What is the ratio of the Employment to population ratio(%) of Benin in 1996 to that in 2000?
Your response must be concise. 1.05. What is the ratio of the Employment to population ratio(%) in Hungary in 1996 to that in 2000?
Offer a terse response. 0.97. What is the ratio of the Employment to population ratio(%) of Moldova in 1996 to that in 2000?
Your answer should be compact. 1.11. What is the ratio of the Employment to population ratio(%) of Singapore in 1996 to that in 2000?
Your answer should be very brief. 1.04. What is the ratio of the Employment to population ratio(%) of Benin in 1997 to that in 1998?
Provide a short and direct response. 1.01. What is the ratio of the Employment to population ratio(%) in Moldova in 1997 to that in 1998?
Keep it short and to the point. 1.05. What is the ratio of the Employment to population ratio(%) of Singapore in 1997 to that in 1998?
Provide a succinct answer. 1.02. What is the ratio of the Employment to population ratio(%) in Benin in 1997 to that in 1999?
Offer a terse response. 1.03. What is the ratio of the Employment to population ratio(%) in Hungary in 1997 to that in 1999?
Provide a short and direct response. 0.98. What is the ratio of the Employment to population ratio(%) in Moldova in 1997 to that in 1999?
Provide a short and direct response. 1.15. What is the ratio of the Employment to population ratio(%) in Singapore in 1997 to that in 1999?
Ensure brevity in your answer.  1.02. What is the ratio of the Employment to population ratio(%) in Benin in 1997 to that in 2000?
Offer a very short reply. 1.04. What is the ratio of the Employment to population ratio(%) of Hungary in 1997 to that in 2000?
Provide a succinct answer. 0.96. What is the ratio of the Employment to population ratio(%) of Moldova in 1997 to that in 2000?
Give a very brief answer. 1.13. What is the ratio of the Employment to population ratio(%) of Singapore in 1997 to that in 2000?
Ensure brevity in your answer.  1.03. What is the ratio of the Employment to population ratio(%) in Benin in 1998 to that in 1999?
Your answer should be very brief. 1.01. What is the ratio of the Employment to population ratio(%) of Moldova in 1998 to that in 1999?
Offer a terse response. 1.1. What is the ratio of the Employment to population ratio(%) of Benin in 1998 to that in 2000?
Provide a short and direct response. 1.03. What is the ratio of the Employment to population ratio(%) in Hungary in 1998 to that in 2000?
Provide a short and direct response. 0.96. What is the ratio of the Employment to population ratio(%) of Moldova in 1998 to that in 2000?
Provide a succinct answer. 1.08. What is the ratio of the Employment to population ratio(%) in Benin in 1999 to that in 2000?
Offer a very short reply. 1.01. What is the ratio of the Employment to population ratio(%) in Hungary in 1999 to that in 2000?
Keep it short and to the point. 0.99. What is the ratio of the Employment to population ratio(%) of Moldova in 1999 to that in 2000?
Provide a short and direct response. 0.98. What is the ratio of the Employment to population ratio(%) in Singapore in 1999 to that in 2000?
Your answer should be very brief. 1. What is the difference between the highest and the second highest Employment to population ratio(%) of Hungary?
Ensure brevity in your answer.  0.6. What is the difference between the highest and the second highest Employment to population ratio(%) of Moldova?
Offer a terse response. 0.8. What is the difference between the highest and the second highest Employment to population ratio(%) in Singapore?
Give a very brief answer. 0.2. What is the difference between the highest and the lowest Employment to population ratio(%) in Benin?
Your answer should be compact. 6.4. What is the difference between the highest and the lowest Employment to population ratio(%) in Hungary?
Your answer should be very brief. 2.2. What is the difference between the highest and the lowest Employment to population ratio(%) in Singapore?
Ensure brevity in your answer.  3.3. 